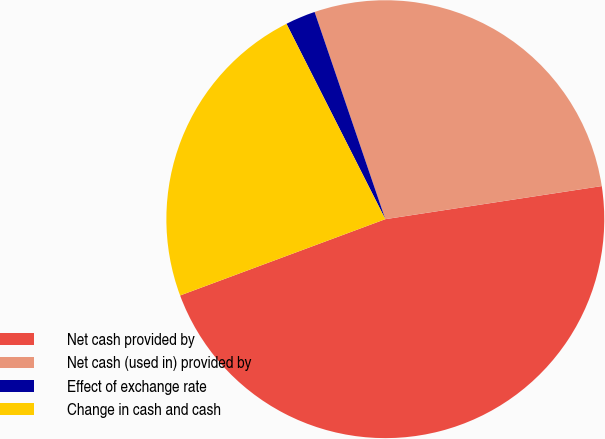Convert chart. <chart><loc_0><loc_0><loc_500><loc_500><pie_chart><fcel>Net cash provided by<fcel>Net cash (used in) provided by<fcel>Effect of exchange rate<fcel>Change in cash and cash<nl><fcel>46.75%<fcel>27.82%<fcel>2.22%<fcel>23.21%<nl></chart> 